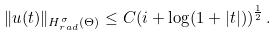<formula> <loc_0><loc_0><loc_500><loc_500>\| u ( t ) \| _ { H ^ { \sigma } _ { r a d } ( \Theta ) } \leq C ( i + \log ( 1 + | t | ) ) ^ { \frac { 1 } { 2 } } \, .</formula> 